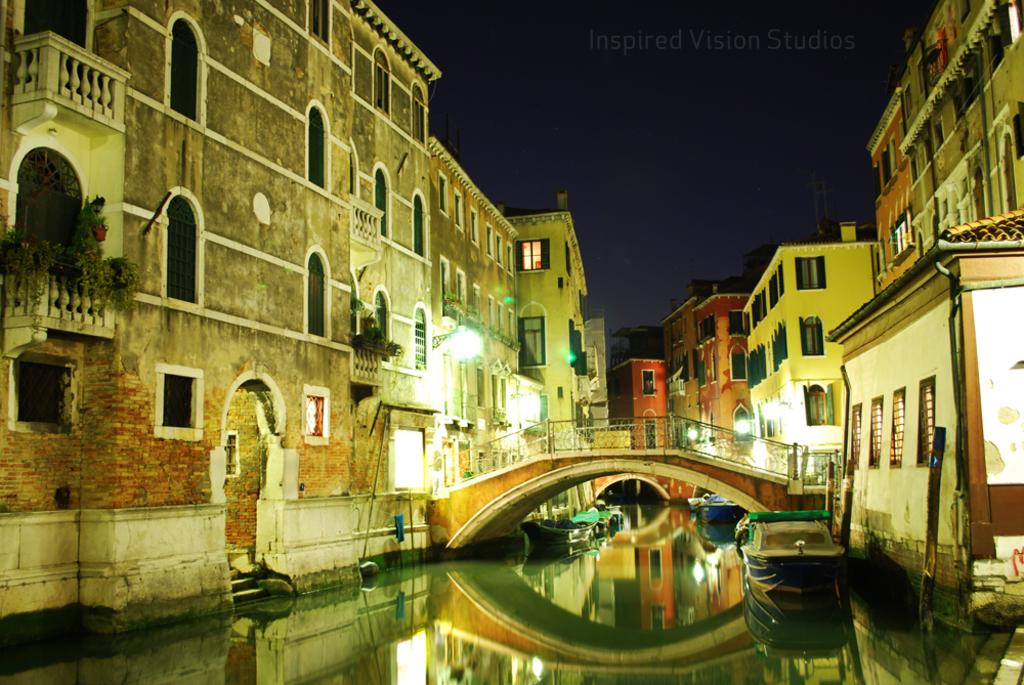What is on the surface of the water in the image? There are boats on the surface of the water in the image. What can be seen in the background of the image? There is a bridge and buildings in the background of the image. What is visible at the top of the image? The sky is visible at the top of the image. What type of stick can be seen on the floor in the image? There is no stick or floor present in the image; it features boats on water, a bridge, buildings, and the sky. 